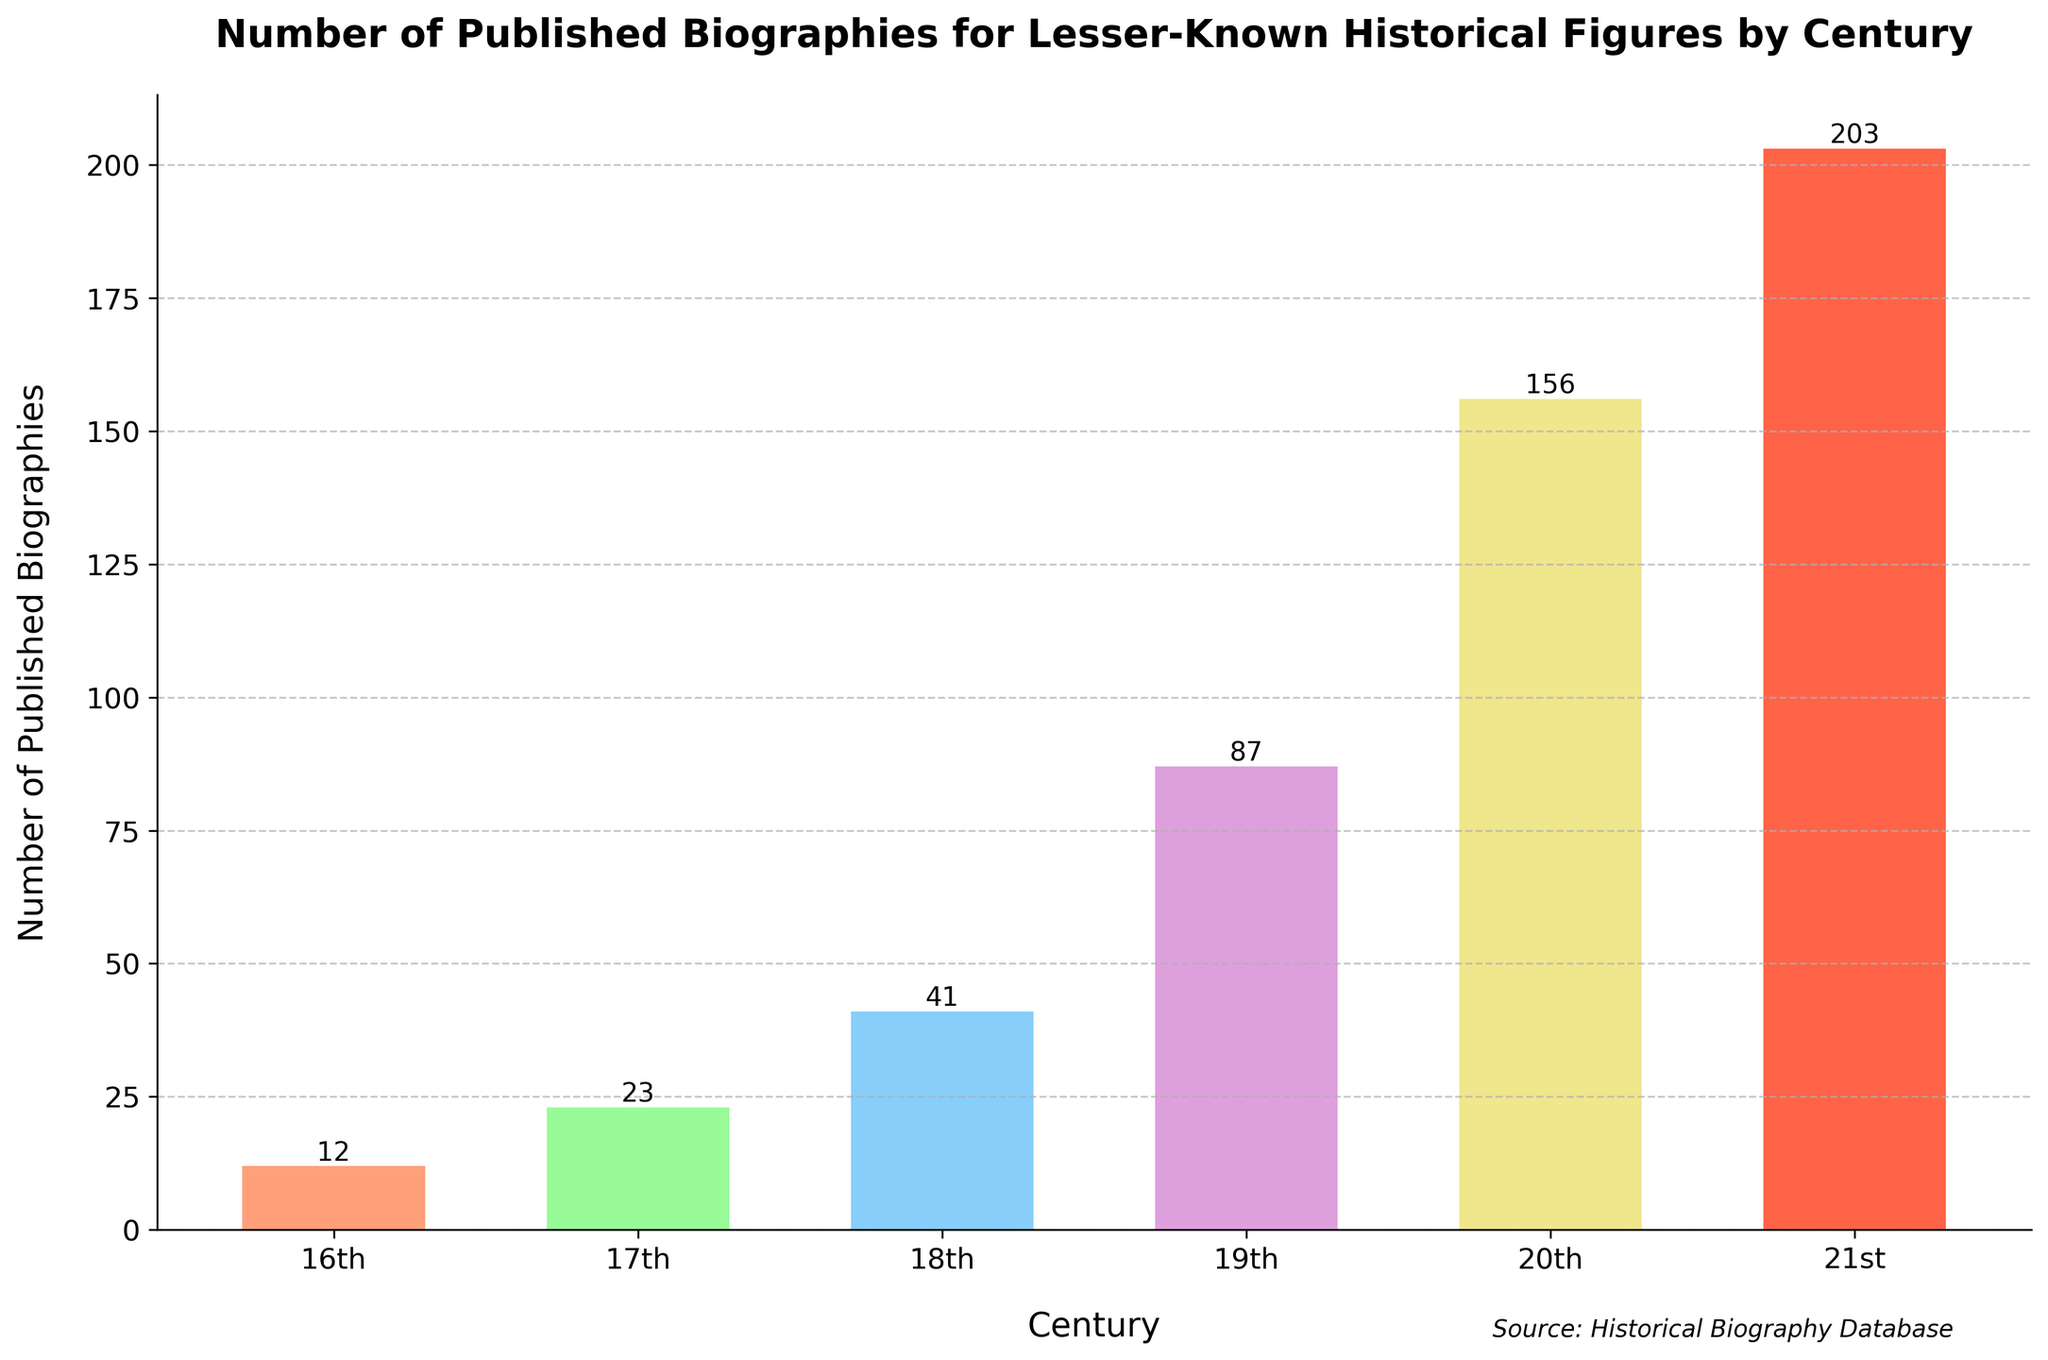What is the total number of published biographies across all centuries? First, we find the number of published biographies for each century: 12 (16th) + 23 (17th) + 41 (18th) + 87 (19th) + 156 (20th) + 203 (21st). Adding these together gives a total of 522.
Answer: 522 Which century saw the highest number of published biographies? By observing the heights of the bars, the tallest bar represents the 21st century with 203 published biographies. Therefore, the 21st century saw the highest number.
Answer: 21st century How many more biographies were published in the 20th century compared to the 16th century? The number of published biographies in the 20th century is 156, and in the 16th century, it is 12. The difference is 156 - 12 = 144, indicating 144 more biographies were published in the 20th century.
Answer: 144 What is the average number of published biographies per century? To find the average, sum the total number of biographies (522) and divide by the number of centuries (6). Therefore, the average is 522 / 6 = 87.
Answer: 87 Between which two centuries did the number of published biographies increase the most? We calculate the differences between consecutive centuries: 17th-16th (23-12=11), 18th-17th (41-23=18), 19th-18th (87-41=46), 20th-19th (156-87=69), and 21st-20th (203-156=47). The largest increase is from the 19th to the 20th century with 69.
Answer: 19th to 20th Which century had the smallest relative increase from the previous century? Calculating the relative increases: 17th-16th (11/12 ≈ 0.92), 18th-17th (18/23 ≈ 0.78), 19th-18th (46/41 ≈ 1.12), 20th-19th (69/87 ≈ 0.79), and 21st-20th (47/156 ≈ 0.30). The 21st century had the smallest relative increase (0.30).
Answer: 21st century What are the colors of the bars representing the 19th and 20th centuries? By visually inspecting the chart, the bar for the 19th century is a light purple, and the bar for the 20th century is a yellowish color.
Answer: Light purple and yellow Considering the visual attributes, which century’s bar is the third tallest? Observing the heights of the bars, after the 21st and 20th centuries, the next tallest bar represents the 19th century with 87 published biographies.
Answer: 19th century 